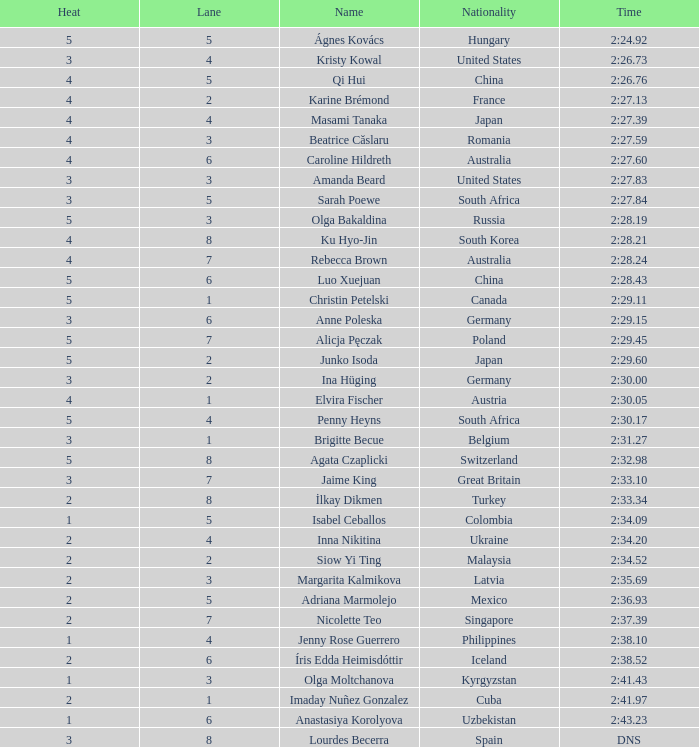What is the name associated with witnessing 4 heats and having a lane number greater than 7? Ku Hyo-Jin. 